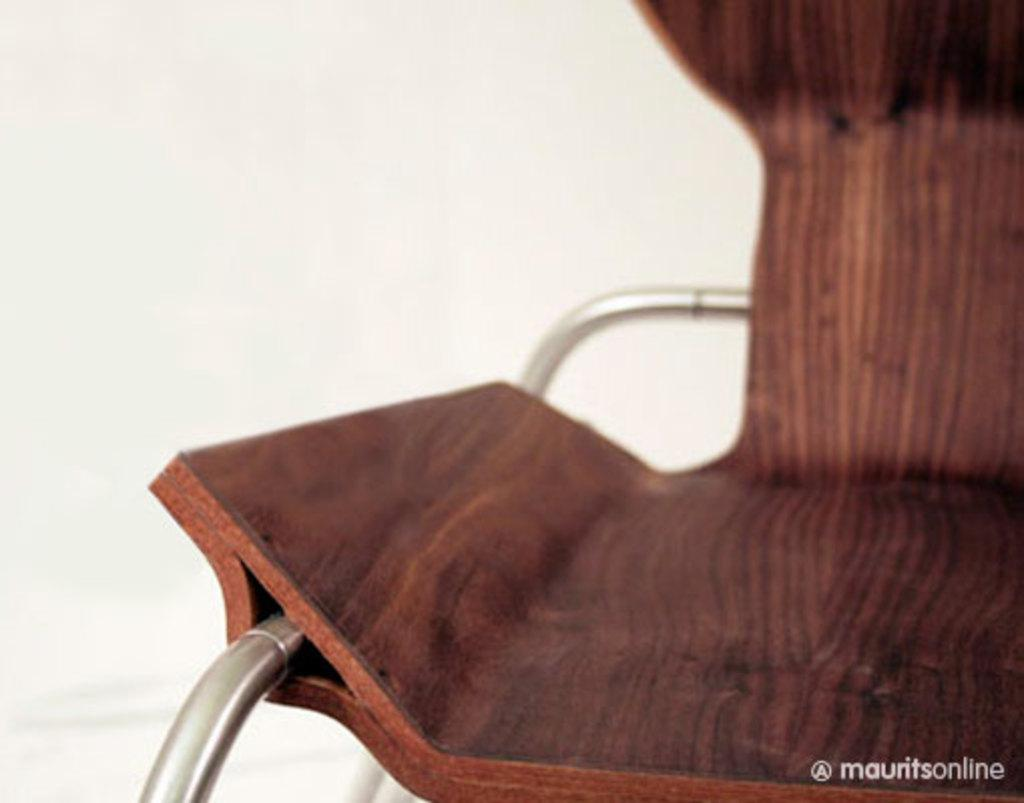What type of furniture is visible in the image? There is a chair in the image. Where is the chair located in relation to the image? The chair is in front of the image. What can be seen behind the chair? There is a wall behind the chair. What is written or depicted at the bottom of the image? There is some text at the bottom of the image. Can you see the seashore in the image? No, there is no seashore present in the image. Is the chair floating in space in the image? No, the chair is not in space; it is in front of a wall. Is there any oil visible in the image? No, there is no oil present in the image. 